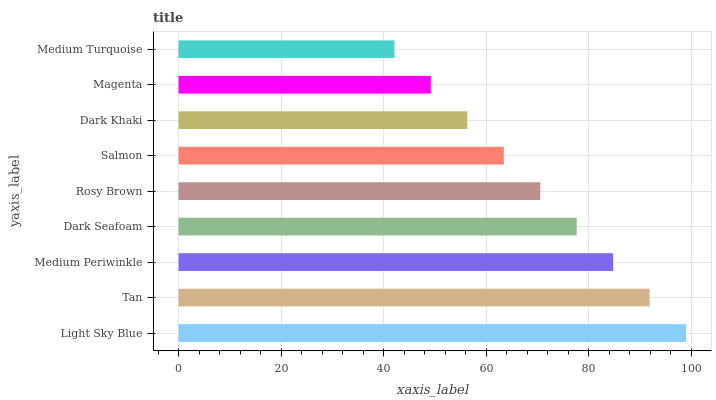Is Medium Turquoise the minimum?
Answer yes or no. Yes. Is Light Sky Blue the maximum?
Answer yes or no. Yes. Is Tan the minimum?
Answer yes or no. No. Is Tan the maximum?
Answer yes or no. No. Is Light Sky Blue greater than Tan?
Answer yes or no. Yes. Is Tan less than Light Sky Blue?
Answer yes or no. Yes. Is Tan greater than Light Sky Blue?
Answer yes or no. No. Is Light Sky Blue less than Tan?
Answer yes or no. No. Is Rosy Brown the high median?
Answer yes or no. Yes. Is Rosy Brown the low median?
Answer yes or no. Yes. Is Light Sky Blue the high median?
Answer yes or no. No. Is Light Sky Blue the low median?
Answer yes or no. No. 